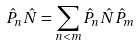Convert formula to latex. <formula><loc_0><loc_0><loc_500><loc_500>\hat { P } _ { n } \hat { N } = \sum _ { n < m } \hat { P } _ { n } \hat { N } \hat { P } _ { m }</formula> 